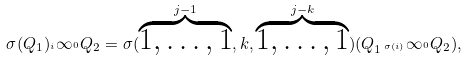<formula> <loc_0><loc_0><loc_500><loc_500>\sigma ( Q _ { 1 } ) _ { ^ { i } } \infty _ { ^ { 0 } } Q _ { 2 } = \sigma ( \stackrel { j - 1 } { \overbrace { 1 , \dots , 1 } } , k , \stackrel { j - k } { \overbrace { 1 , \dots , 1 } } ) ( Q _ { 1 \, ^ { \sigma ( i ) } } \infty _ { ^ { 0 } } Q _ { 2 } ) ,</formula> 